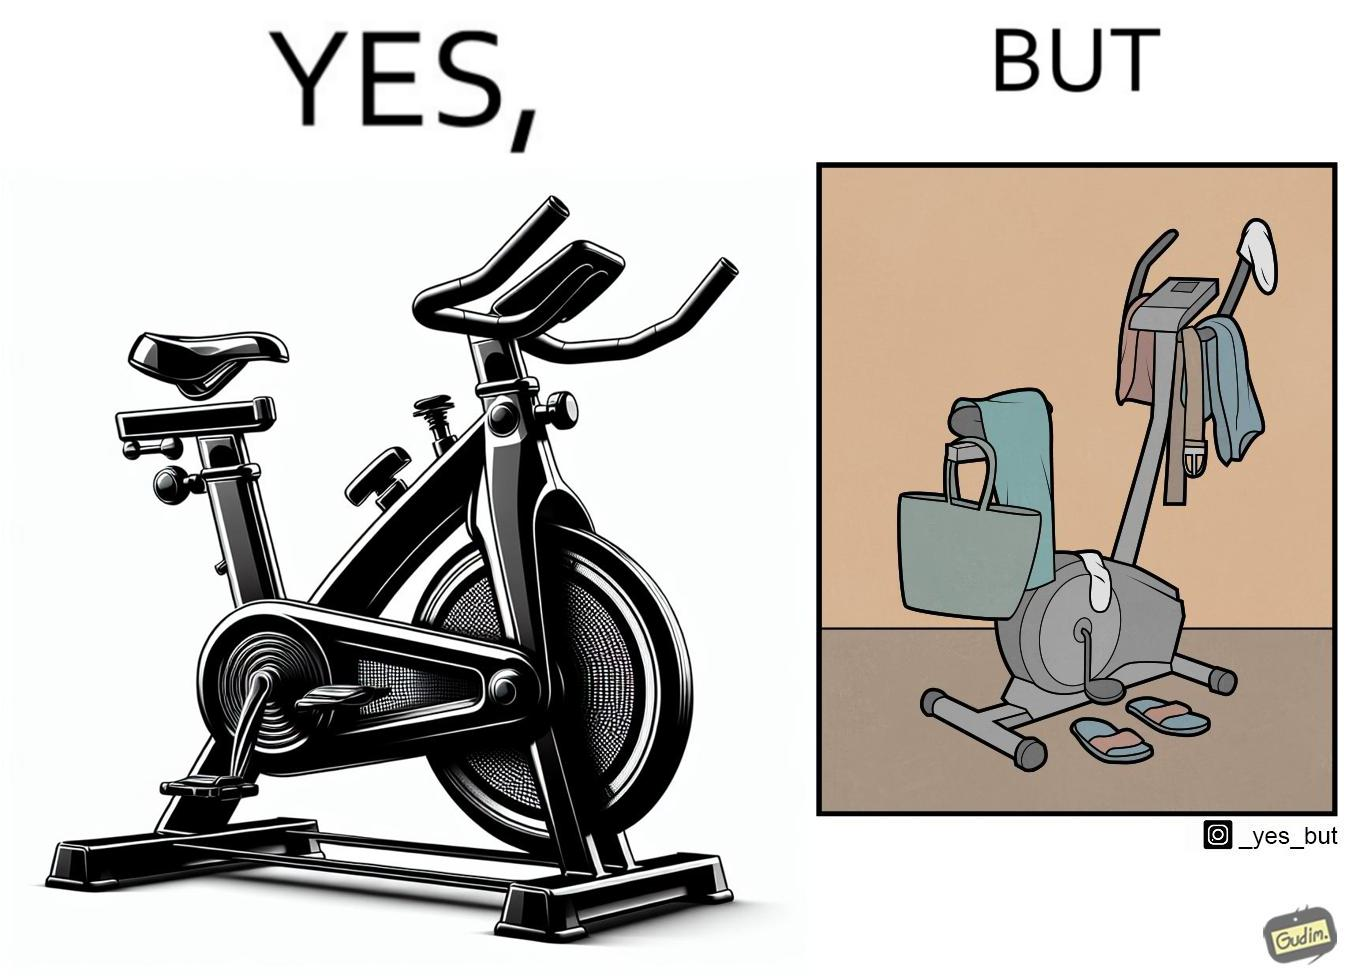Is this a satirical image? Yes, this image is satirical. 